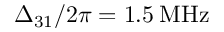<formula> <loc_0><loc_0><loc_500><loc_500>\Delta _ { 3 1 } / 2 \pi = 1 . 5 \, M H z</formula> 